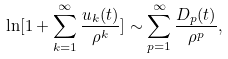<formula> <loc_0><loc_0><loc_500><loc_500>\ln [ 1 + \sum _ { k = 1 } ^ { \infty } \frac { u _ { k } ( t ) } { \rho ^ { k } } ] \sim \sum _ { p = 1 } ^ { \infty } \frac { D _ { p } ( t ) } { \rho ^ { p } } ,</formula> 